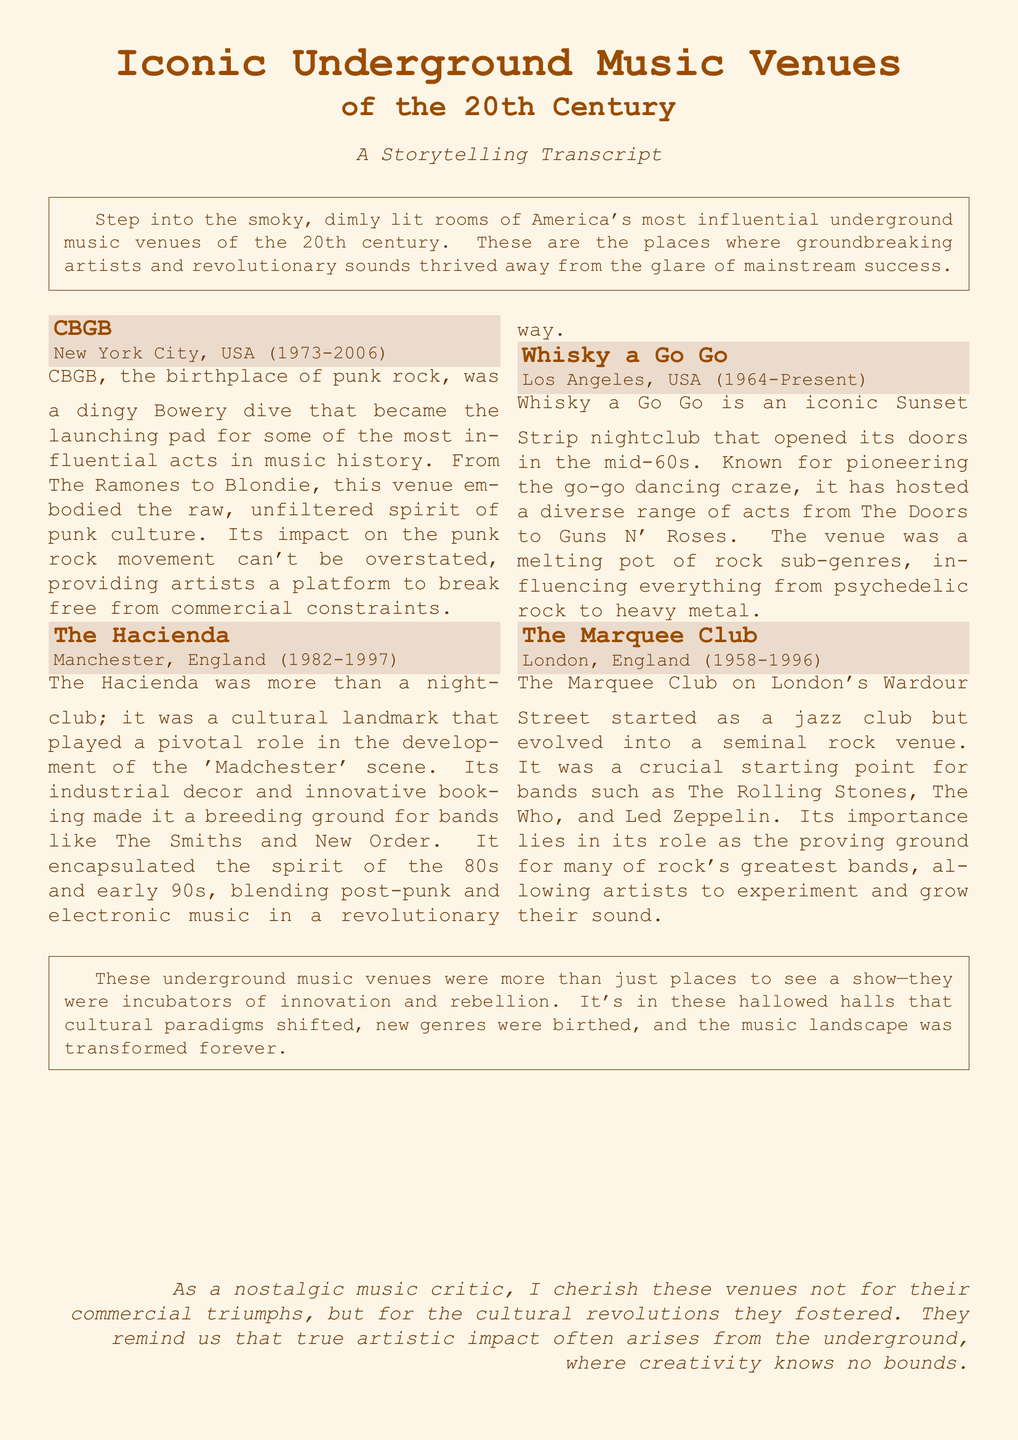What year did CBGB open? CBGB opened its doors in 1973 as stated in the document.
Answer: 1973 Which band is associated with The Hacienda? The document mentions The Smiths as one of the bands that thrived at The Hacienda.
Answer: The Smiths What city is Whisky a Go Go located in? The document specifies that Whisky a Go Go is located in Los Angeles, USA.
Answer: Los Angeles What genre is CBGB best known for? The venue CBGB is best known for being the birthplace of punk rock according to the document.
Answer: Punk rock How long did The Marquee Club operate? The document states that The Marquee Club operated from 1958 to 1996, making it 38 years.
Answer: 38 years What cultural movement did The Hacienda contribute to? The Hacienda played a pivotal role in the 'Madchester' scene as highlighted in the document.
Answer: 'Madchester' scene What is the primary theme of the venues discussed in the document? The venues discussed in the document are characterized as incubators of innovation and rebellion.
Answer: Innovation and rebellion In what year did The Hacienda close? The document indicates that The Hacienda closed in 1997.
Answer: 1997 